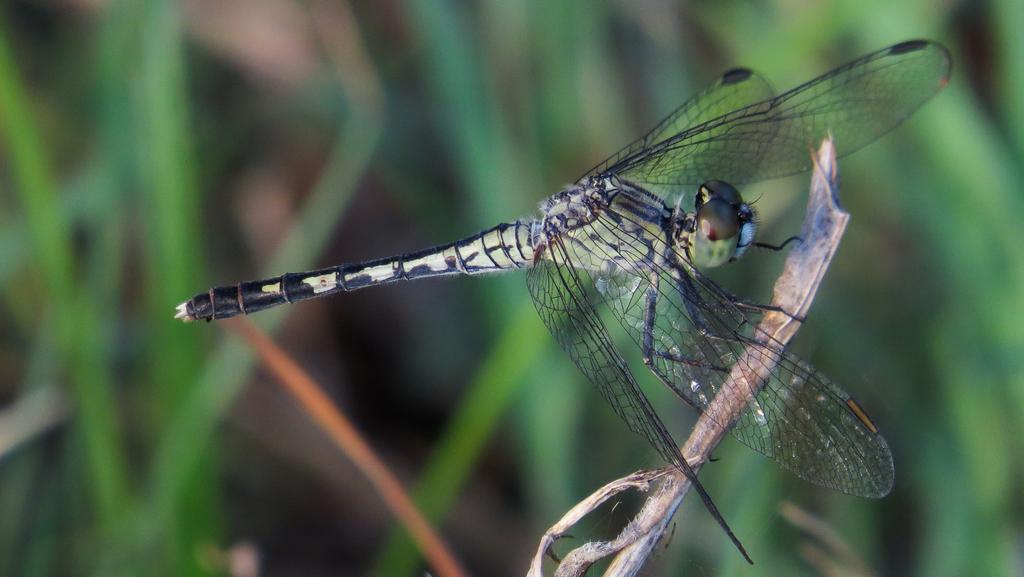What type of insect is in the image? There is a dragonfly in the image. What colors can be seen on the dragonfly? The dragonfly has black and green colors. Where is the dragonfly located in the image? The dragonfly is on a plant. How would you describe the background of the image? The background of the image is blurred. What type of drink is the dragonfly holding in the image? There is no drink present in the image, and the dragonfly does not have the ability to hold objects. 